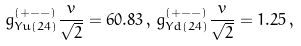Convert formula to latex. <formula><loc_0><loc_0><loc_500><loc_500>g _ { Y u ( 2 4 ) } ^ { ( + - - ) } \frac { v } { \sqrt { 2 } } = 6 0 . 8 3 \, , \, g _ { Y d ( 2 4 ) } ^ { ( + - - ) } \frac { v } { \sqrt { 2 } } = 1 . 2 5 \, ,</formula> 